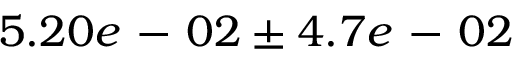<formula> <loc_0><loc_0><loc_500><loc_500>5 . 2 0 e - 0 2 \pm 4 . 7 e - 0 2</formula> 